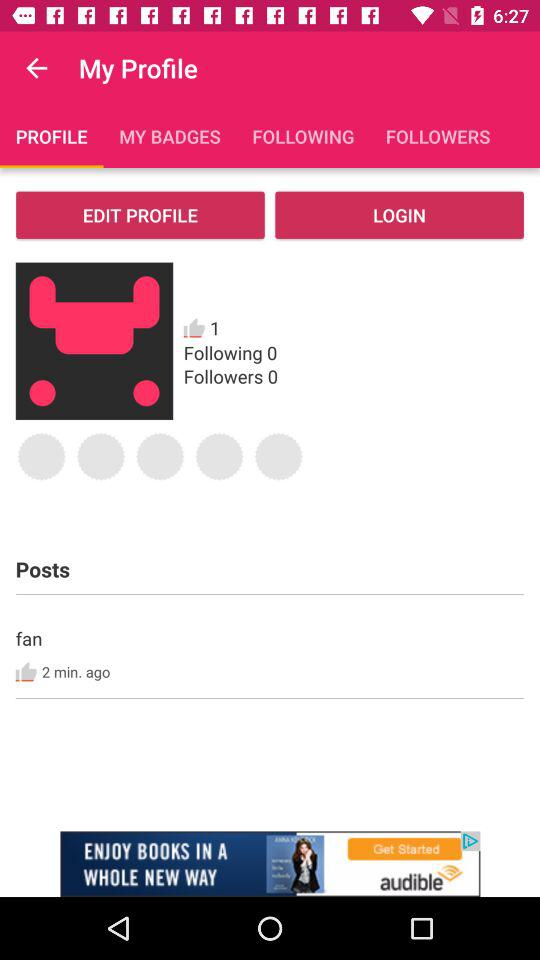How many likes are there? There is 1 like. 